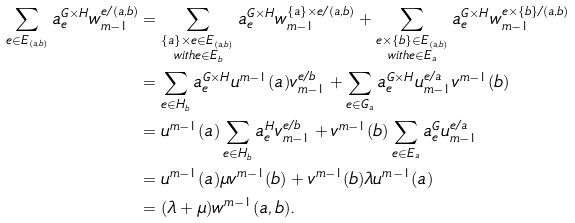Convert formula to latex. <formula><loc_0><loc_0><loc_500><loc_500>\sum _ { e \in E _ { ( a , b ) } } a _ { e } ^ { G \times H } w ^ { e / { ( a , b ) } } _ { m - 1 } & = \sum _ { \substack { \{ a \} \times e \in E _ { ( a , b ) } \\ w i t h e \in E _ { b } } } a _ { e } ^ { G \times H } w ^ { \{ a \} \times e / ( a , b ) } _ { m - 1 } + \sum _ { \substack { e \times \{ b \} \in E _ { ( a , b ) } \\ w i t h e \in E _ { a } } } a _ { e } ^ { G \times H } w ^ { e \times \{ b \} / ( a , b ) } _ { m - 1 } \\ & = \sum _ { e \in H _ { b } } a _ { e } ^ { G \times H } u ^ { m - 1 } ( a ) v ^ { e / b } _ { m - 1 } + \sum _ { e \in G _ { a } } a _ { e } ^ { G \times H } u ^ { e / a } _ { m - 1 } v ^ { m - 1 } ( b ) \\ & = u ^ { m - 1 } ( a ) \sum _ { e \in H _ { b } } a _ { e } ^ { H } v _ { m - 1 } ^ { e / b } + v ^ { m - 1 } ( b ) \sum _ { e \in E _ { a } } a _ { e } ^ { G } u ^ { e / a } _ { m - 1 } \\ & = u ^ { m - 1 } ( a ) \mu v ^ { m - 1 } ( b ) + v ^ { m - 1 } ( b ) \lambda u ^ { m - 1 } ( a ) \\ & = ( \lambda + \mu ) w ^ { m - 1 } ( a , b ) .</formula> 